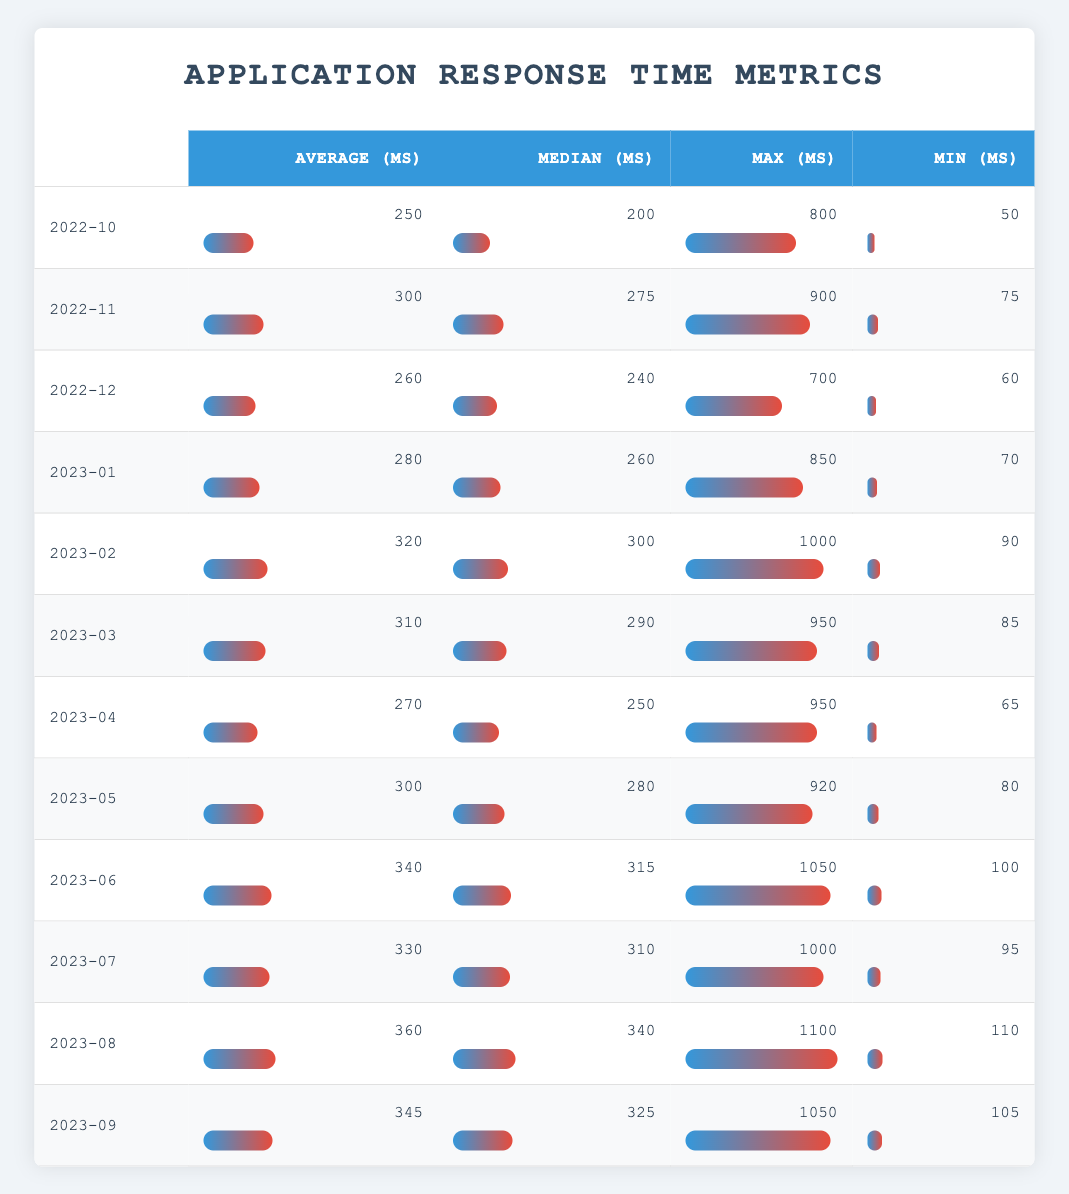What was the maximum response time recorded in October 2022? In the row corresponding to October 2022, the maximum response time is listed as 800 ms.
Answer: 800 ms What is the average response time over the last 12 months? To find the average, we sum the average response times for all months: (250 + 300 + 260 + 280 + 320 + 310 + 270 + 300 + 340 + 330 + 360 + 345) = 3,060. There are 12 months, so the average is 3,060 / 12 = 255 ms.
Answer: 255 ms Did the minimum response time increase from December 2022 to January 2023? The minimum response times are 60 ms for December 2022 and 70 ms for January 2023. Since 70 ms is greater than 60 ms, the minimum increased.
Answer: Yes What month had the highest median response time? Inspecting the table, the months of August 2023 and September 2023 both have a median response time of 340 ms and 325 ms, respectively. Thus, the highest median is in August 2023.
Answer: August 2023 What is the difference between the maximum response times in February 2023 and March 2023? The maximum response time in February 2023 is 1000 ms, and in March 2023 it is 950 ms. The difference is 1000 - 950 = 50 ms.
Answer: 50 ms Was the average response time in July 2023 higher than in June 2023? The average response time for June 2023 is 340 ms, while for July 2023 it is 330 ms. Since 330 ms is less than 340 ms, the average in July is not higher.
Answer: No What is the total sum of average response times from January 2023 to August 2023? We add the average response times for these months: (280 + 320 + 310 + 270 + 300 + 340 + 330 + 360) = 2,220 ms.
Answer: 2,220 ms How many months had an average response time greater than 300 ms? Looking through the table, only the months of February, June, July, and August 2023 have average response times greater than 300 ms. This totals to 4 months.
Answer: 4 months 